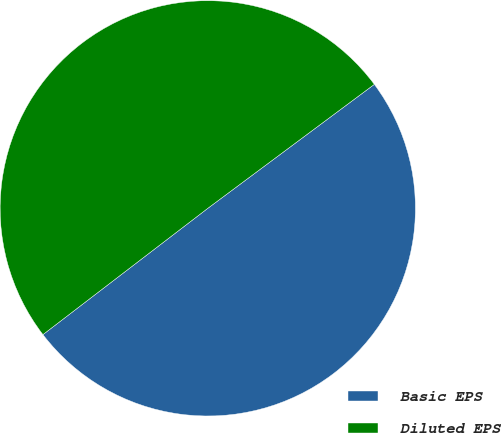<chart> <loc_0><loc_0><loc_500><loc_500><pie_chart><fcel>Basic EPS<fcel>Diluted EPS<nl><fcel>49.78%<fcel>50.22%<nl></chart> 